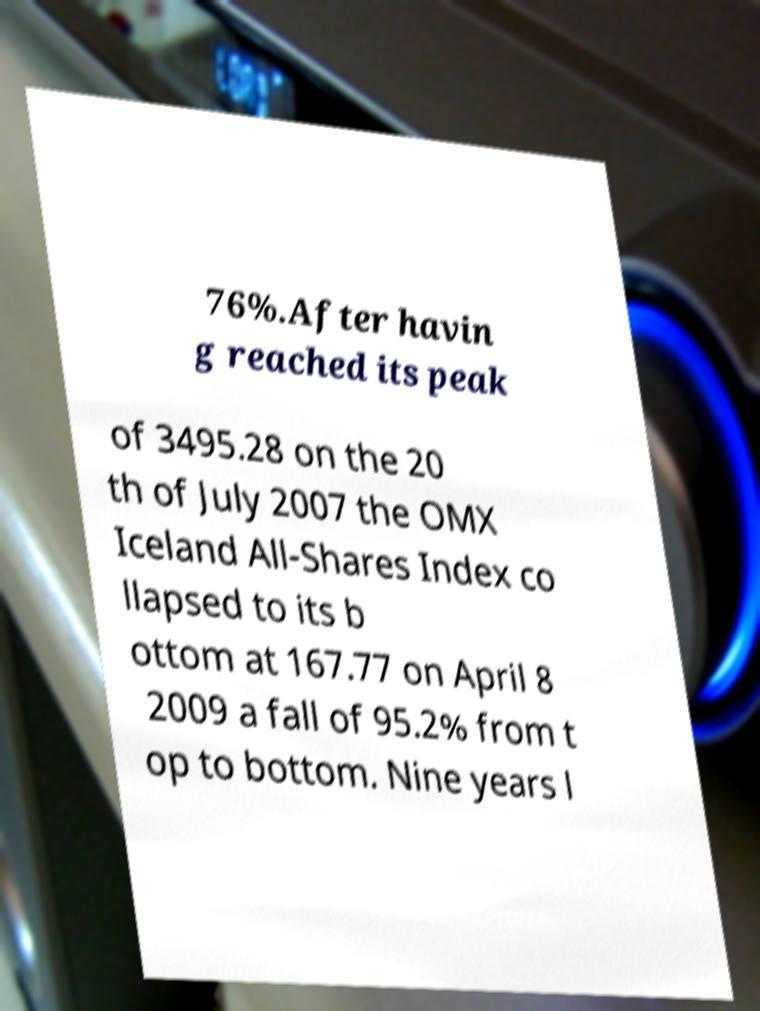What messages or text are displayed in this image? I need them in a readable, typed format. 76%.After havin g reached its peak of 3495.28 on the 20 th of July 2007 the OMX Iceland All-Shares Index co llapsed to its b ottom at 167.77 on April 8 2009 a fall of 95.2% from t op to bottom. Nine years l 